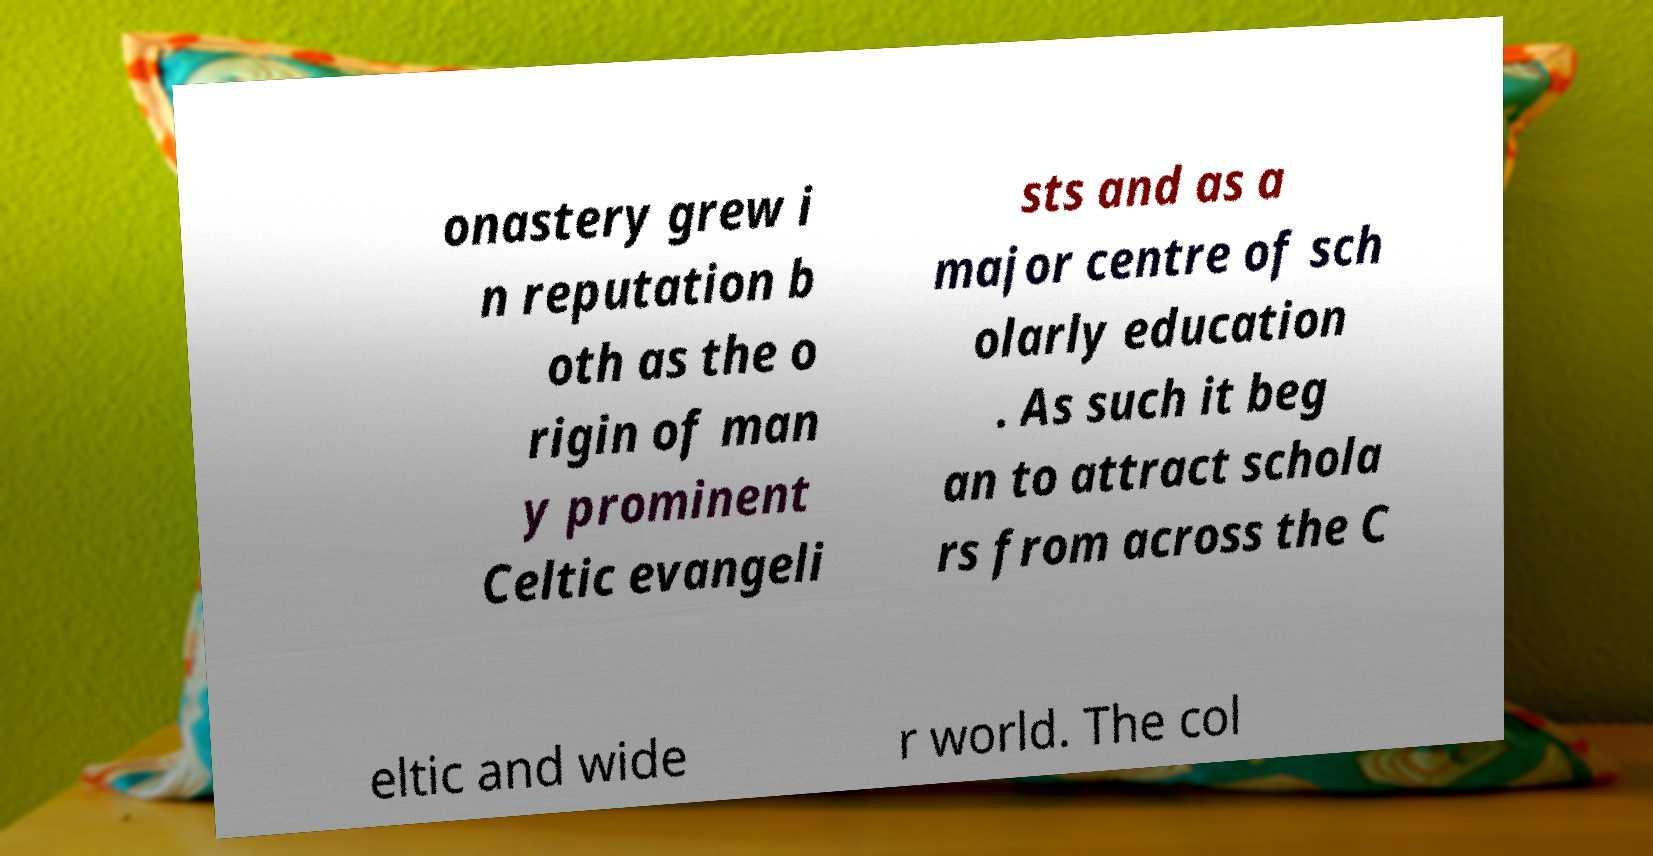Please identify and transcribe the text found in this image. onastery grew i n reputation b oth as the o rigin of man y prominent Celtic evangeli sts and as a major centre of sch olarly education . As such it beg an to attract schola rs from across the C eltic and wide r world. The col 